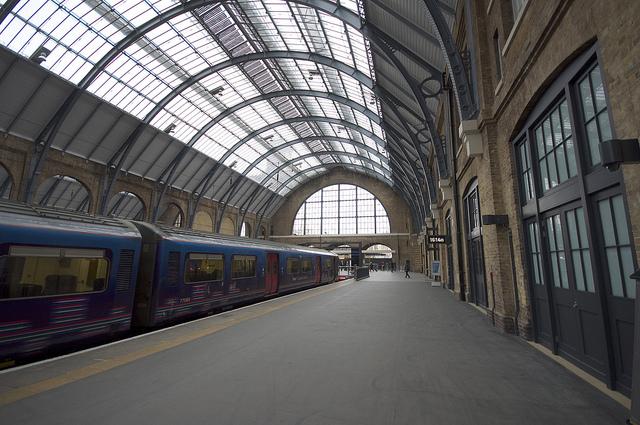Is this a crowded station?
Short answer required. No. What is on the ceiling?
Quick response, please. Glass. Is the roof glass?
Give a very brief answer. Yes. Is there a design on the ceiling?
Write a very short answer. No. How many train tracks are there?
Concise answer only. 1. What is the shape of the roof?
Short answer required. Round. 